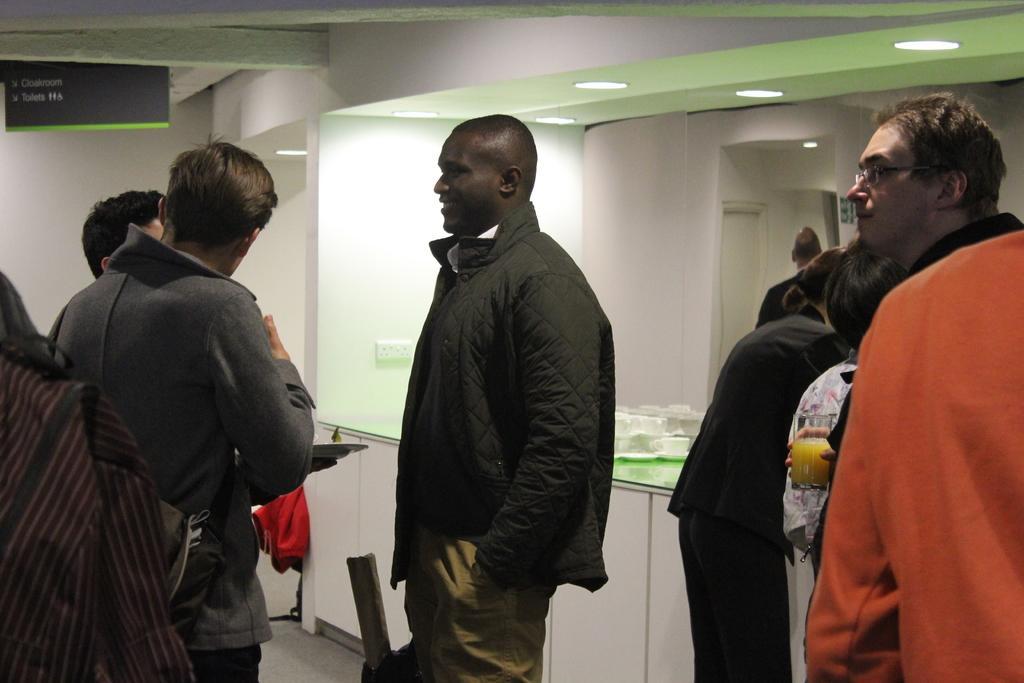How would you summarize this image in a sentence or two? In this picture I can see few people standing and looks like a man holding a plate in his hand and I can see few cups on the table and I can see another man holding a glass in his hand and I can see few lights on the ceiling and a board with some text and I can see a mirror and I can see reflection of a human and a door in the mirror. 